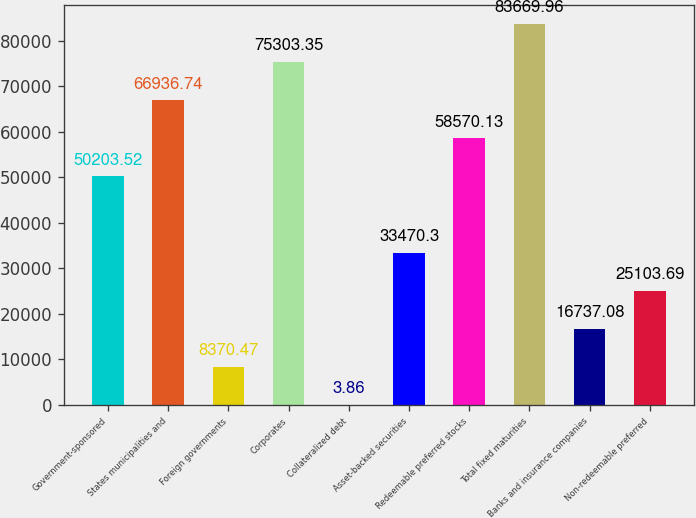Convert chart to OTSL. <chart><loc_0><loc_0><loc_500><loc_500><bar_chart><fcel>Government-sponsored<fcel>States municipalities and<fcel>Foreign governments<fcel>Corporates<fcel>Collateralized debt<fcel>Asset-backed securities<fcel>Redeemable preferred stocks<fcel>Total fixed maturities<fcel>Banks and insurance companies<fcel>Non-redeemable preferred<nl><fcel>50203.5<fcel>66936.7<fcel>8370.47<fcel>75303.4<fcel>3.86<fcel>33470.3<fcel>58570.1<fcel>83670<fcel>16737.1<fcel>25103.7<nl></chart> 